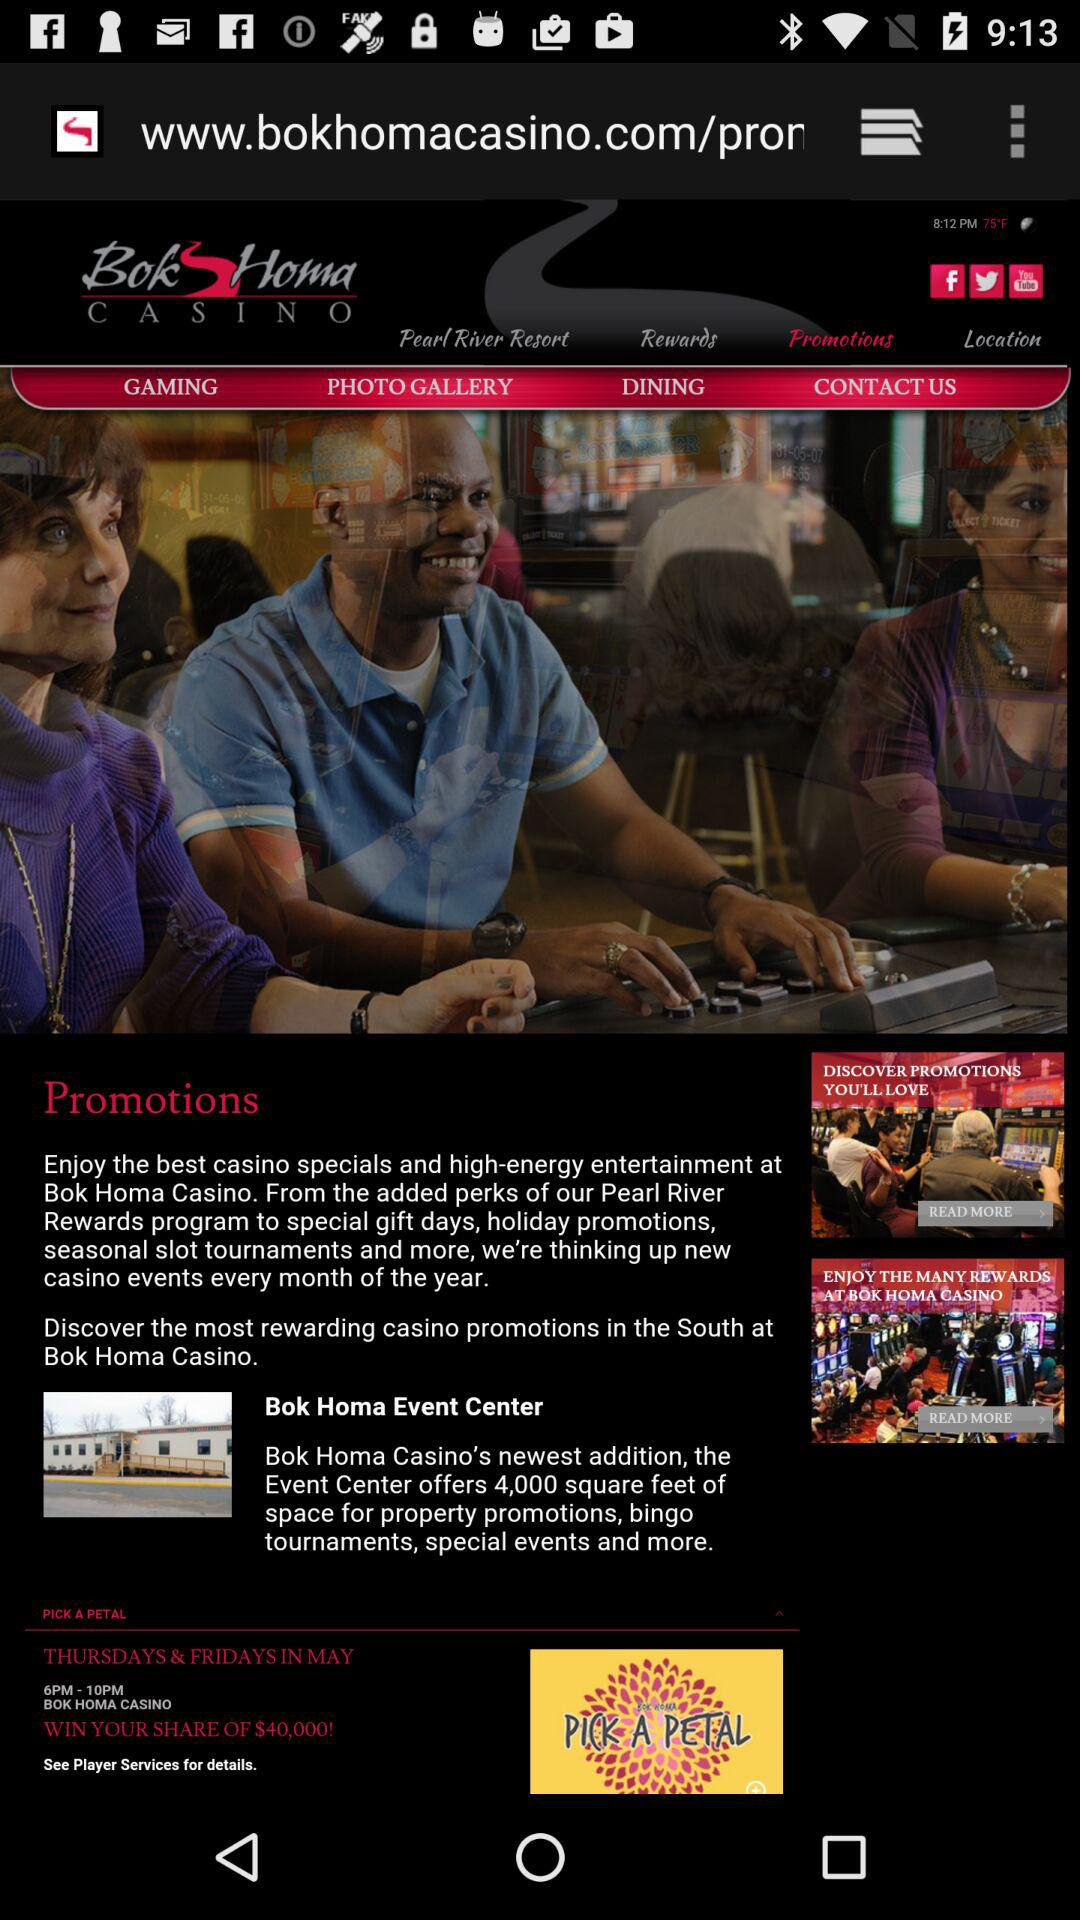What is the name of the application? The name of the application is "Bok Homa CASINO". 